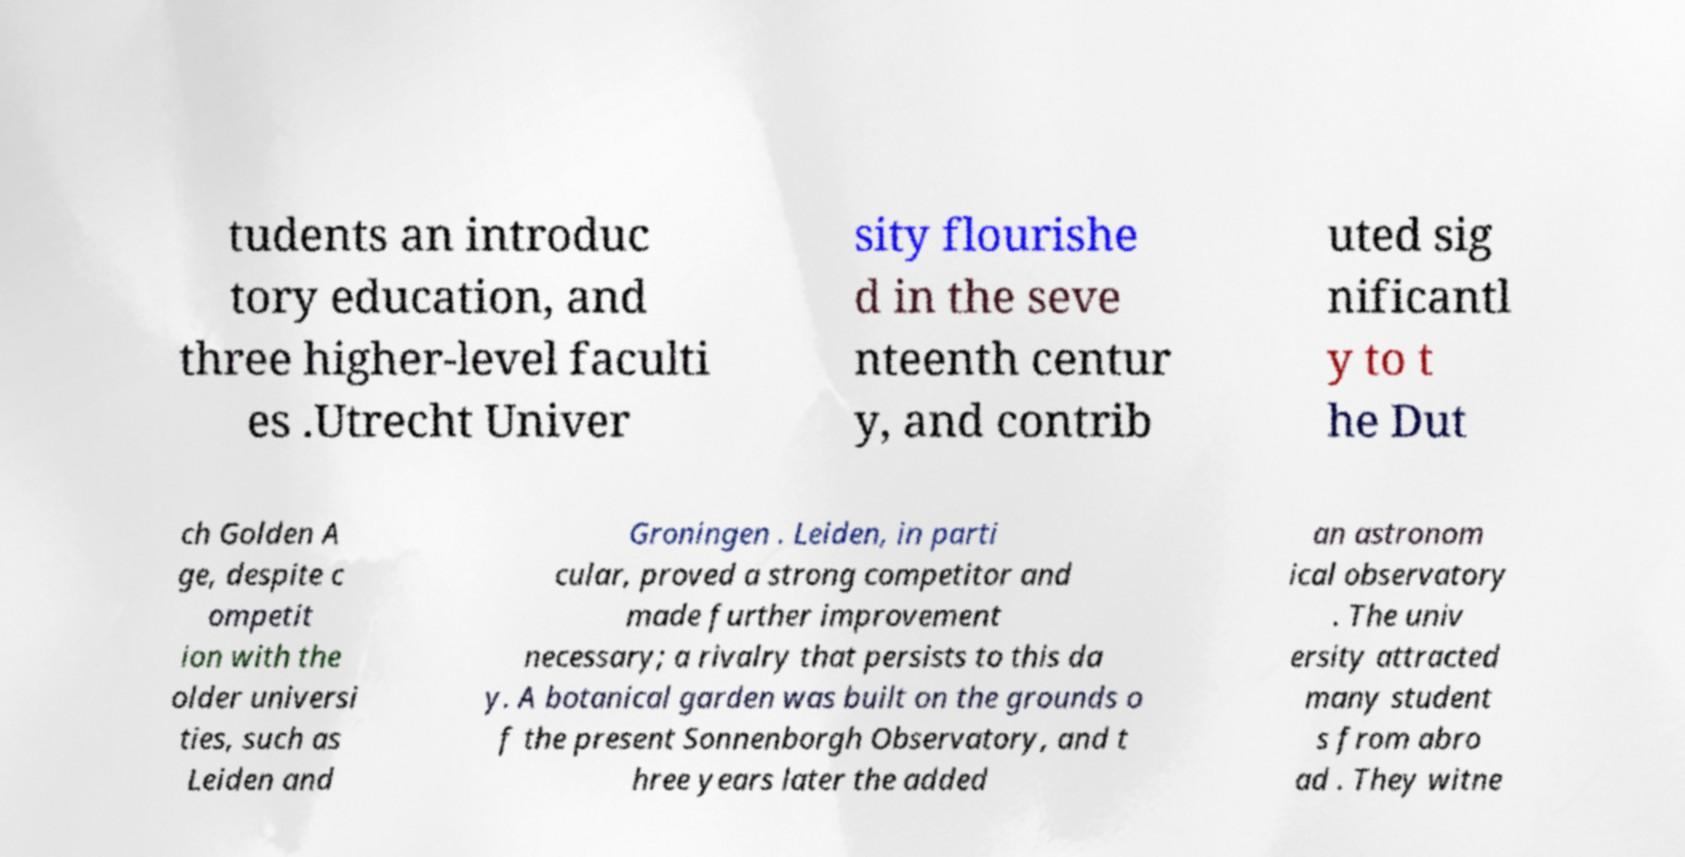What messages or text are displayed in this image? I need them in a readable, typed format. tudents an introduc tory education, and three higher-level faculti es .Utrecht Univer sity flourishe d in the seve nteenth centur y, and contrib uted sig nificantl y to t he Dut ch Golden A ge, despite c ompetit ion with the older universi ties, such as Leiden and Groningen . Leiden, in parti cular, proved a strong competitor and made further improvement necessary; a rivalry that persists to this da y. A botanical garden was built on the grounds o f the present Sonnenborgh Observatory, and t hree years later the added an astronom ical observatory . The univ ersity attracted many student s from abro ad . They witne 